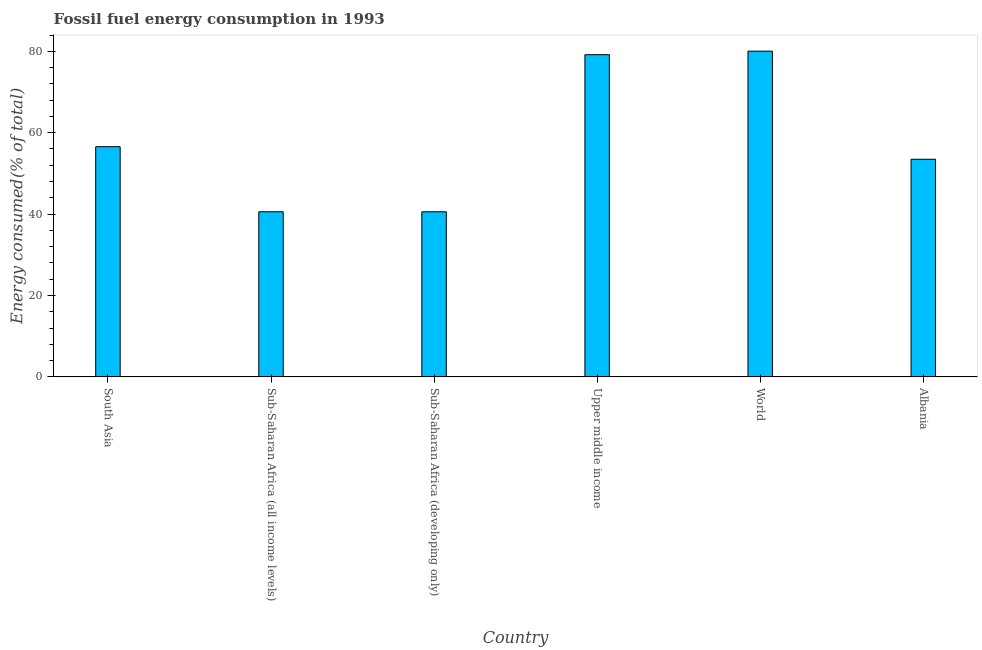Does the graph contain any zero values?
Your answer should be very brief. No. What is the title of the graph?
Provide a short and direct response. Fossil fuel energy consumption in 1993. What is the label or title of the X-axis?
Provide a succinct answer. Country. What is the label or title of the Y-axis?
Your response must be concise. Energy consumed(% of total). What is the fossil fuel energy consumption in Sub-Saharan Africa (developing only)?
Your answer should be very brief. 40.57. Across all countries, what is the maximum fossil fuel energy consumption?
Your response must be concise. 80.04. Across all countries, what is the minimum fossil fuel energy consumption?
Offer a terse response. 40.57. In which country was the fossil fuel energy consumption minimum?
Offer a very short reply. Sub-Saharan Africa (all income levels). What is the sum of the fossil fuel energy consumption?
Make the answer very short. 350.4. What is the average fossil fuel energy consumption per country?
Offer a terse response. 58.4. What is the median fossil fuel energy consumption?
Provide a short and direct response. 55.02. What is the ratio of the fossil fuel energy consumption in Albania to that in World?
Offer a terse response. 0.67. Is the fossil fuel energy consumption in Upper middle income less than that in World?
Offer a terse response. Yes. What is the difference between the highest and the second highest fossil fuel energy consumption?
Your response must be concise. 0.87. Is the sum of the fossil fuel energy consumption in Sub-Saharan Africa (developing only) and Upper middle income greater than the maximum fossil fuel energy consumption across all countries?
Your response must be concise. Yes. What is the difference between the highest and the lowest fossil fuel energy consumption?
Keep it short and to the point. 39.47. How many bars are there?
Make the answer very short. 6. Are the values on the major ticks of Y-axis written in scientific E-notation?
Your answer should be compact. No. What is the Energy consumed(% of total) of South Asia?
Keep it short and to the point. 56.56. What is the Energy consumed(% of total) in Sub-Saharan Africa (all income levels)?
Provide a succinct answer. 40.57. What is the Energy consumed(% of total) of Sub-Saharan Africa (developing only)?
Offer a terse response. 40.57. What is the Energy consumed(% of total) in Upper middle income?
Provide a succinct answer. 79.17. What is the Energy consumed(% of total) of World?
Provide a short and direct response. 80.04. What is the Energy consumed(% of total) of Albania?
Offer a very short reply. 53.48. What is the difference between the Energy consumed(% of total) in South Asia and Sub-Saharan Africa (all income levels)?
Provide a short and direct response. 15.99. What is the difference between the Energy consumed(% of total) in South Asia and Sub-Saharan Africa (developing only)?
Your answer should be compact. 15.99. What is the difference between the Energy consumed(% of total) in South Asia and Upper middle income?
Make the answer very short. -22.61. What is the difference between the Energy consumed(% of total) in South Asia and World?
Offer a very short reply. -23.48. What is the difference between the Energy consumed(% of total) in South Asia and Albania?
Provide a succinct answer. 3.09. What is the difference between the Energy consumed(% of total) in Sub-Saharan Africa (all income levels) and Upper middle income?
Your answer should be very brief. -38.6. What is the difference between the Energy consumed(% of total) in Sub-Saharan Africa (all income levels) and World?
Ensure brevity in your answer.  -39.47. What is the difference between the Energy consumed(% of total) in Sub-Saharan Africa (all income levels) and Albania?
Offer a very short reply. -12.91. What is the difference between the Energy consumed(% of total) in Sub-Saharan Africa (developing only) and Upper middle income?
Offer a terse response. -38.6. What is the difference between the Energy consumed(% of total) in Sub-Saharan Africa (developing only) and World?
Make the answer very short. -39.47. What is the difference between the Energy consumed(% of total) in Sub-Saharan Africa (developing only) and Albania?
Your answer should be compact. -12.91. What is the difference between the Energy consumed(% of total) in Upper middle income and World?
Provide a short and direct response. -0.87. What is the difference between the Energy consumed(% of total) in Upper middle income and Albania?
Your answer should be compact. 25.69. What is the difference between the Energy consumed(% of total) in World and Albania?
Keep it short and to the point. 26.56. What is the ratio of the Energy consumed(% of total) in South Asia to that in Sub-Saharan Africa (all income levels)?
Your answer should be compact. 1.39. What is the ratio of the Energy consumed(% of total) in South Asia to that in Sub-Saharan Africa (developing only)?
Provide a succinct answer. 1.39. What is the ratio of the Energy consumed(% of total) in South Asia to that in Upper middle income?
Offer a very short reply. 0.71. What is the ratio of the Energy consumed(% of total) in South Asia to that in World?
Your response must be concise. 0.71. What is the ratio of the Energy consumed(% of total) in South Asia to that in Albania?
Your answer should be very brief. 1.06. What is the ratio of the Energy consumed(% of total) in Sub-Saharan Africa (all income levels) to that in Sub-Saharan Africa (developing only)?
Offer a very short reply. 1. What is the ratio of the Energy consumed(% of total) in Sub-Saharan Africa (all income levels) to that in Upper middle income?
Offer a terse response. 0.51. What is the ratio of the Energy consumed(% of total) in Sub-Saharan Africa (all income levels) to that in World?
Provide a succinct answer. 0.51. What is the ratio of the Energy consumed(% of total) in Sub-Saharan Africa (all income levels) to that in Albania?
Keep it short and to the point. 0.76. What is the ratio of the Energy consumed(% of total) in Sub-Saharan Africa (developing only) to that in Upper middle income?
Offer a very short reply. 0.51. What is the ratio of the Energy consumed(% of total) in Sub-Saharan Africa (developing only) to that in World?
Your response must be concise. 0.51. What is the ratio of the Energy consumed(% of total) in Sub-Saharan Africa (developing only) to that in Albania?
Make the answer very short. 0.76. What is the ratio of the Energy consumed(% of total) in Upper middle income to that in Albania?
Provide a short and direct response. 1.48. What is the ratio of the Energy consumed(% of total) in World to that in Albania?
Offer a terse response. 1.5. 